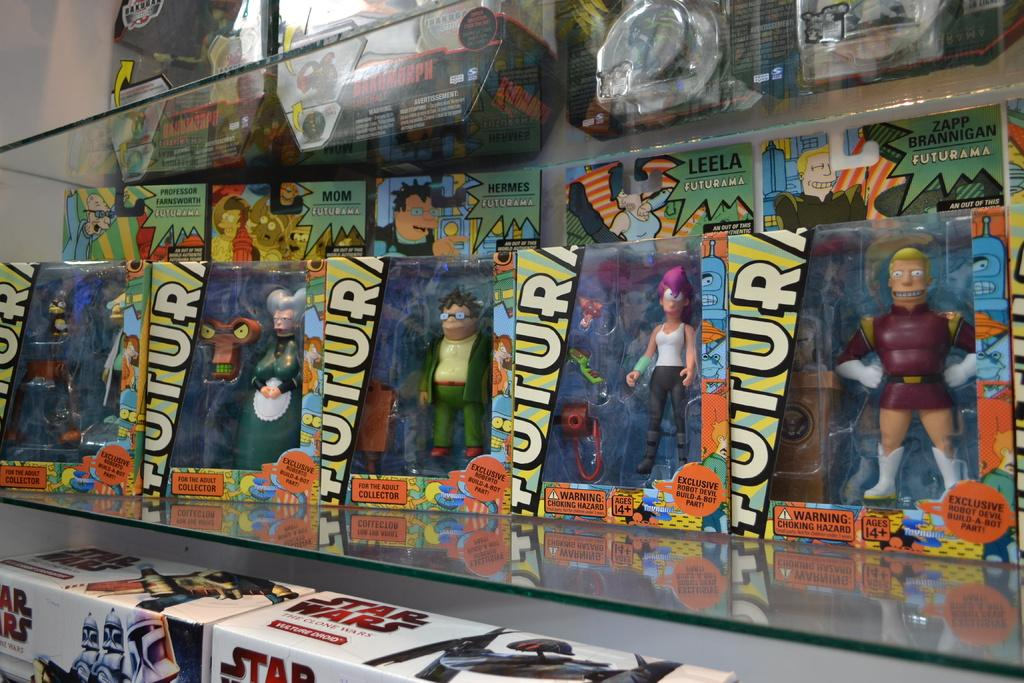<image>
Provide a brief description of the given image. A row of Futurama action figures are on a toy shelf. 